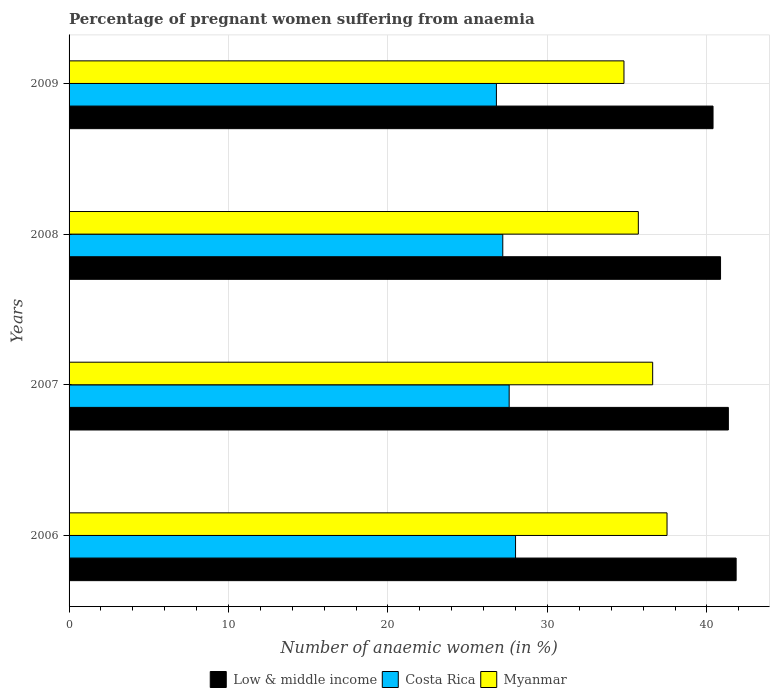How many different coloured bars are there?
Ensure brevity in your answer.  3. Are the number of bars per tick equal to the number of legend labels?
Give a very brief answer. Yes. How many bars are there on the 2nd tick from the top?
Give a very brief answer. 3. How many bars are there on the 4th tick from the bottom?
Your answer should be very brief. 3. In how many cases, is the number of bars for a given year not equal to the number of legend labels?
Provide a succinct answer. 0. What is the number of anaemic women in Myanmar in 2008?
Give a very brief answer. 35.7. Across all years, what is the minimum number of anaemic women in Costa Rica?
Your response must be concise. 26.8. In which year was the number of anaemic women in Costa Rica maximum?
Provide a short and direct response. 2006. What is the total number of anaemic women in Costa Rica in the graph?
Offer a very short reply. 109.6. What is the difference between the number of anaemic women in Costa Rica in 2008 and that in 2009?
Your answer should be compact. 0.4. What is the difference between the number of anaemic women in Myanmar in 2006 and the number of anaemic women in Low & middle income in 2007?
Your answer should be compact. -3.85. What is the average number of anaemic women in Low & middle income per year?
Give a very brief answer. 41.11. In the year 2009, what is the difference between the number of anaemic women in Costa Rica and number of anaemic women in Low & middle income?
Your answer should be compact. -13.59. In how many years, is the number of anaemic women in Myanmar greater than 18 %?
Offer a very short reply. 4. What is the ratio of the number of anaemic women in Low & middle income in 2007 to that in 2008?
Keep it short and to the point. 1.01. Is the difference between the number of anaemic women in Costa Rica in 2006 and 2008 greater than the difference between the number of anaemic women in Low & middle income in 2006 and 2008?
Provide a succinct answer. No. What is the difference between the highest and the second highest number of anaemic women in Costa Rica?
Give a very brief answer. 0.4. What is the difference between the highest and the lowest number of anaemic women in Costa Rica?
Make the answer very short. 1.2. What does the 3rd bar from the bottom in 2009 represents?
Offer a very short reply. Myanmar. How many bars are there?
Offer a very short reply. 12. What is the difference between two consecutive major ticks on the X-axis?
Your answer should be compact. 10. Does the graph contain any zero values?
Keep it short and to the point. No. How many legend labels are there?
Make the answer very short. 3. How are the legend labels stacked?
Keep it short and to the point. Horizontal. What is the title of the graph?
Make the answer very short. Percentage of pregnant women suffering from anaemia. Does "Tajikistan" appear as one of the legend labels in the graph?
Keep it short and to the point. No. What is the label or title of the X-axis?
Provide a short and direct response. Number of anaemic women (in %). What is the label or title of the Y-axis?
Provide a succinct answer. Years. What is the Number of anaemic women (in %) in Low & middle income in 2006?
Provide a short and direct response. 41.83. What is the Number of anaemic women (in %) in Costa Rica in 2006?
Keep it short and to the point. 28. What is the Number of anaemic women (in %) in Myanmar in 2006?
Offer a very short reply. 37.5. What is the Number of anaemic women (in %) in Low & middle income in 2007?
Provide a short and direct response. 41.35. What is the Number of anaemic women (in %) of Costa Rica in 2007?
Provide a short and direct response. 27.6. What is the Number of anaemic women (in %) in Myanmar in 2007?
Make the answer very short. 36.6. What is the Number of anaemic women (in %) of Low & middle income in 2008?
Your response must be concise. 40.86. What is the Number of anaemic women (in %) of Costa Rica in 2008?
Your answer should be very brief. 27.2. What is the Number of anaemic women (in %) of Myanmar in 2008?
Provide a short and direct response. 35.7. What is the Number of anaemic women (in %) of Low & middle income in 2009?
Offer a very short reply. 40.39. What is the Number of anaemic women (in %) in Costa Rica in 2009?
Give a very brief answer. 26.8. What is the Number of anaemic women (in %) of Myanmar in 2009?
Your answer should be compact. 34.8. Across all years, what is the maximum Number of anaemic women (in %) in Low & middle income?
Ensure brevity in your answer.  41.83. Across all years, what is the maximum Number of anaemic women (in %) in Myanmar?
Offer a very short reply. 37.5. Across all years, what is the minimum Number of anaemic women (in %) in Low & middle income?
Make the answer very short. 40.39. Across all years, what is the minimum Number of anaemic women (in %) in Costa Rica?
Ensure brevity in your answer.  26.8. Across all years, what is the minimum Number of anaemic women (in %) of Myanmar?
Make the answer very short. 34.8. What is the total Number of anaemic women (in %) of Low & middle income in the graph?
Give a very brief answer. 164.42. What is the total Number of anaemic women (in %) in Costa Rica in the graph?
Keep it short and to the point. 109.6. What is the total Number of anaemic women (in %) of Myanmar in the graph?
Give a very brief answer. 144.6. What is the difference between the Number of anaemic women (in %) of Low & middle income in 2006 and that in 2007?
Ensure brevity in your answer.  0.49. What is the difference between the Number of anaemic women (in %) of Myanmar in 2006 and that in 2007?
Offer a very short reply. 0.9. What is the difference between the Number of anaemic women (in %) of Low & middle income in 2006 and that in 2008?
Your response must be concise. 0.98. What is the difference between the Number of anaemic women (in %) in Costa Rica in 2006 and that in 2008?
Keep it short and to the point. 0.8. What is the difference between the Number of anaemic women (in %) of Low & middle income in 2006 and that in 2009?
Keep it short and to the point. 1.45. What is the difference between the Number of anaemic women (in %) of Costa Rica in 2006 and that in 2009?
Your answer should be compact. 1.2. What is the difference between the Number of anaemic women (in %) in Low & middle income in 2007 and that in 2008?
Provide a succinct answer. 0.49. What is the difference between the Number of anaemic women (in %) in Costa Rica in 2007 and that in 2008?
Offer a very short reply. 0.4. What is the difference between the Number of anaemic women (in %) of Low & middle income in 2007 and that in 2009?
Offer a very short reply. 0.96. What is the difference between the Number of anaemic women (in %) of Costa Rica in 2007 and that in 2009?
Offer a terse response. 0.8. What is the difference between the Number of anaemic women (in %) of Low & middle income in 2008 and that in 2009?
Give a very brief answer. 0.47. What is the difference between the Number of anaemic women (in %) in Costa Rica in 2008 and that in 2009?
Ensure brevity in your answer.  0.4. What is the difference between the Number of anaemic women (in %) in Low & middle income in 2006 and the Number of anaemic women (in %) in Costa Rica in 2007?
Offer a very short reply. 14.23. What is the difference between the Number of anaemic women (in %) in Low & middle income in 2006 and the Number of anaemic women (in %) in Myanmar in 2007?
Your answer should be compact. 5.23. What is the difference between the Number of anaemic women (in %) of Low & middle income in 2006 and the Number of anaemic women (in %) of Costa Rica in 2008?
Your answer should be compact. 14.63. What is the difference between the Number of anaemic women (in %) in Low & middle income in 2006 and the Number of anaemic women (in %) in Myanmar in 2008?
Keep it short and to the point. 6.13. What is the difference between the Number of anaemic women (in %) in Low & middle income in 2006 and the Number of anaemic women (in %) in Costa Rica in 2009?
Give a very brief answer. 15.03. What is the difference between the Number of anaemic women (in %) of Low & middle income in 2006 and the Number of anaemic women (in %) of Myanmar in 2009?
Offer a terse response. 7.03. What is the difference between the Number of anaemic women (in %) in Low & middle income in 2007 and the Number of anaemic women (in %) in Costa Rica in 2008?
Provide a succinct answer. 14.15. What is the difference between the Number of anaemic women (in %) of Low & middle income in 2007 and the Number of anaemic women (in %) of Myanmar in 2008?
Your answer should be compact. 5.65. What is the difference between the Number of anaemic women (in %) in Costa Rica in 2007 and the Number of anaemic women (in %) in Myanmar in 2008?
Ensure brevity in your answer.  -8.1. What is the difference between the Number of anaemic women (in %) in Low & middle income in 2007 and the Number of anaemic women (in %) in Costa Rica in 2009?
Keep it short and to the point. 14.55. What is the difference between the Number of anaemic women (in %) of Low & middle income in 2007 and the Number of anaemic women (in %) of Myanmar in 2009?
Offer a terse response. 6.55. What is the difference between the Number of anaemic women (in %) in Low & middle income in 2008 and the Number of anaemic women (in %) in Costa Rica in 2009?
Offer a very short reply. 14.06. What is the difference between the Number of anaemic women (in %) in Low & middle income in 2008 and the Number of anaemic women (in %) in Myanmar in 2009?
Make the answer very short. 6.06. What is the difference between the Number of anaemic women (in %) of Costa Rica in 2008 and the Number of anaemic women (in %) of Myanmar in 2009?
Offer a terse response. -7.6. What is the average Number of anaemic women (in %) of Low & middle income per year?
Offer a very short reply. 41.11. What is the average Number of anaemic women (in %) of Costa Rica per year?
Your answer should be compact. 27.4. What is the average Number of anaemic women (in %) of Myanmar per year?
Your response must be concise. 36.15. In the year 2006, what is the difference between the Number of anaemic women (in %) of Low & middle income and Number of anaemic women (in %) of Costa Rica?
Give a very brief answer. 13.83. In the year 2006, what is the difference between the Number of anaemic women (in %) in Low & middle income and Number of anaemic women (in %) in Myanmar?
Offer a very short reply. 4.33. In the year 2007, what is the difference between the Number of anaemic women (in %) in Low & middle income and Number of anaemic women (in %) in Costa Rica?
Your answer should be very brief. 13.75. In the year 2007, what is the difference between the Number of anaemic women (in %) in Low & middle income and Number of anaemic women (in %) in Myanmar?
Offer a very short reply. 4.75. In the year 2008, what is the difference between the Number of anaemic women (in %) of Low & middle income and Number of anaemic women (in %) of Costa Rica?
Offer a very short reply. 13.66. In the year 2008, what is the difference between the Number of anaemic women (in %) of Low & middle income and Number of anaemic women (in %) of Myanmar?
Give a very brief answer. 5.16. In the year 2009, what is the difference between the Number of anaemic women (in %) of Low & middle income and Number of anaemic women (in %) of Costa Rica?
Your response must be concise. 13.59. In the year 2009, what is the difference between the Number of anaemic women (in %) in Low & middle income and Number of anaemic women (in %) in Myanmar?
Offer a very short reply. 5.59. In the year 2009, what is the difference between the Number of anaemic women (in %) of Costa Rica and Number of anaemic women (in %) of Myanmar?
Your answer should be compact. -8. What is the ratio of the Number of anaemic women (in %) in Low & middle income in 2006 to that in 2007?
Make the answer very short. 1.01. What is the ratio of the Number of anaemic women (in %) in Costa Rica in 2006 to that in 2007?
Offer a very short reply. 1.01. What is the ratio of the Number of anaemic women (in %) in Myanmar in 2006 to that in 2007?
Your answer should be compact. 1.02. What is the ratio of the Number of anaemic women (in %) in Low & middle income in 2006 to that in 2008?
Your answer should be very brief. 1.02. What is the ratio of the Number of anaemic women (in %) of Costa Rica in 2006 to that in 2008?
Your response must be concise. 1.03. What is the ratio of the Number of anaemic women (in %) of Myanmar in 2006 to that in 2008?
Make the answer very short. 1.05. What is the ratio of the Number of anaemic women (in %) in Low & middle income in 2006 to that in 2009?
Make the answer very short. 1.04. What is the ratio of the Number of anaemic women (in %) in Costa Rica in 2006 to that in 2009?
Offer a very short reply. 1.04. What is the ratio of the Number of anaemic women (in %) of Myanmar in 2006 to that in 2009?
Your response must be concise. 1.08. What is the ratio of the Number of anaemic women (in %) in Low & middle income in 2007 to that in 2008?
Keep it short and to the point. 1.01. What is the ratio of the Number of anaemic women (in %) in Costa Rica in 2007 to that in 2008?
Your response must be concise. 1.01. What is the ratio of the Number of anaemic women (in %) in Myanmar in 2007 to that in 2008?
Ensure brevity in your answer.  1.03. What is the ratio of the Number of anaemic women (in %) of Low & middle income in 2007 to that in 2009?
Keep it short and to the point. 1.02. What is the ratio of the Number of anaemic women (in %) of Costa Rica in 2007 to that in 2009?
Your answer should be compact. 1.03. What is the ratio of the Number of anaemic women (in %) of Myanmar in 2007 to that in 2009?
Provide a short and direct response. 1.05. What is the ratio of the Number of anaemic women (in %) of Low & middle income in 2008 to that in 2009?
Provide a succinct answer. 1.01. What is the ratio of the Number of anaemic women (in %) of Costa Rica in 2008 to that in 2009?
Give a very brief answer. 1.01. What is the ratio of the Number of anaemic women (in %) in Myanmar in 2008 to that in 2009?
Offer a terse response. 1.03. What is the difference between the highest and the second highest Number of anaemic women (in %) of Low & middle income?
Your answer should be very brief. 0.49. What is the difference between the highest and the lowest Number of anaemic women (in %) in Low & middle income?
Provide a succinct answer. 1.45. What is the difference between the highest and the lowest Number of anaemic women (in %) of Myanmar?
Offer a very short reply. 2.7. 